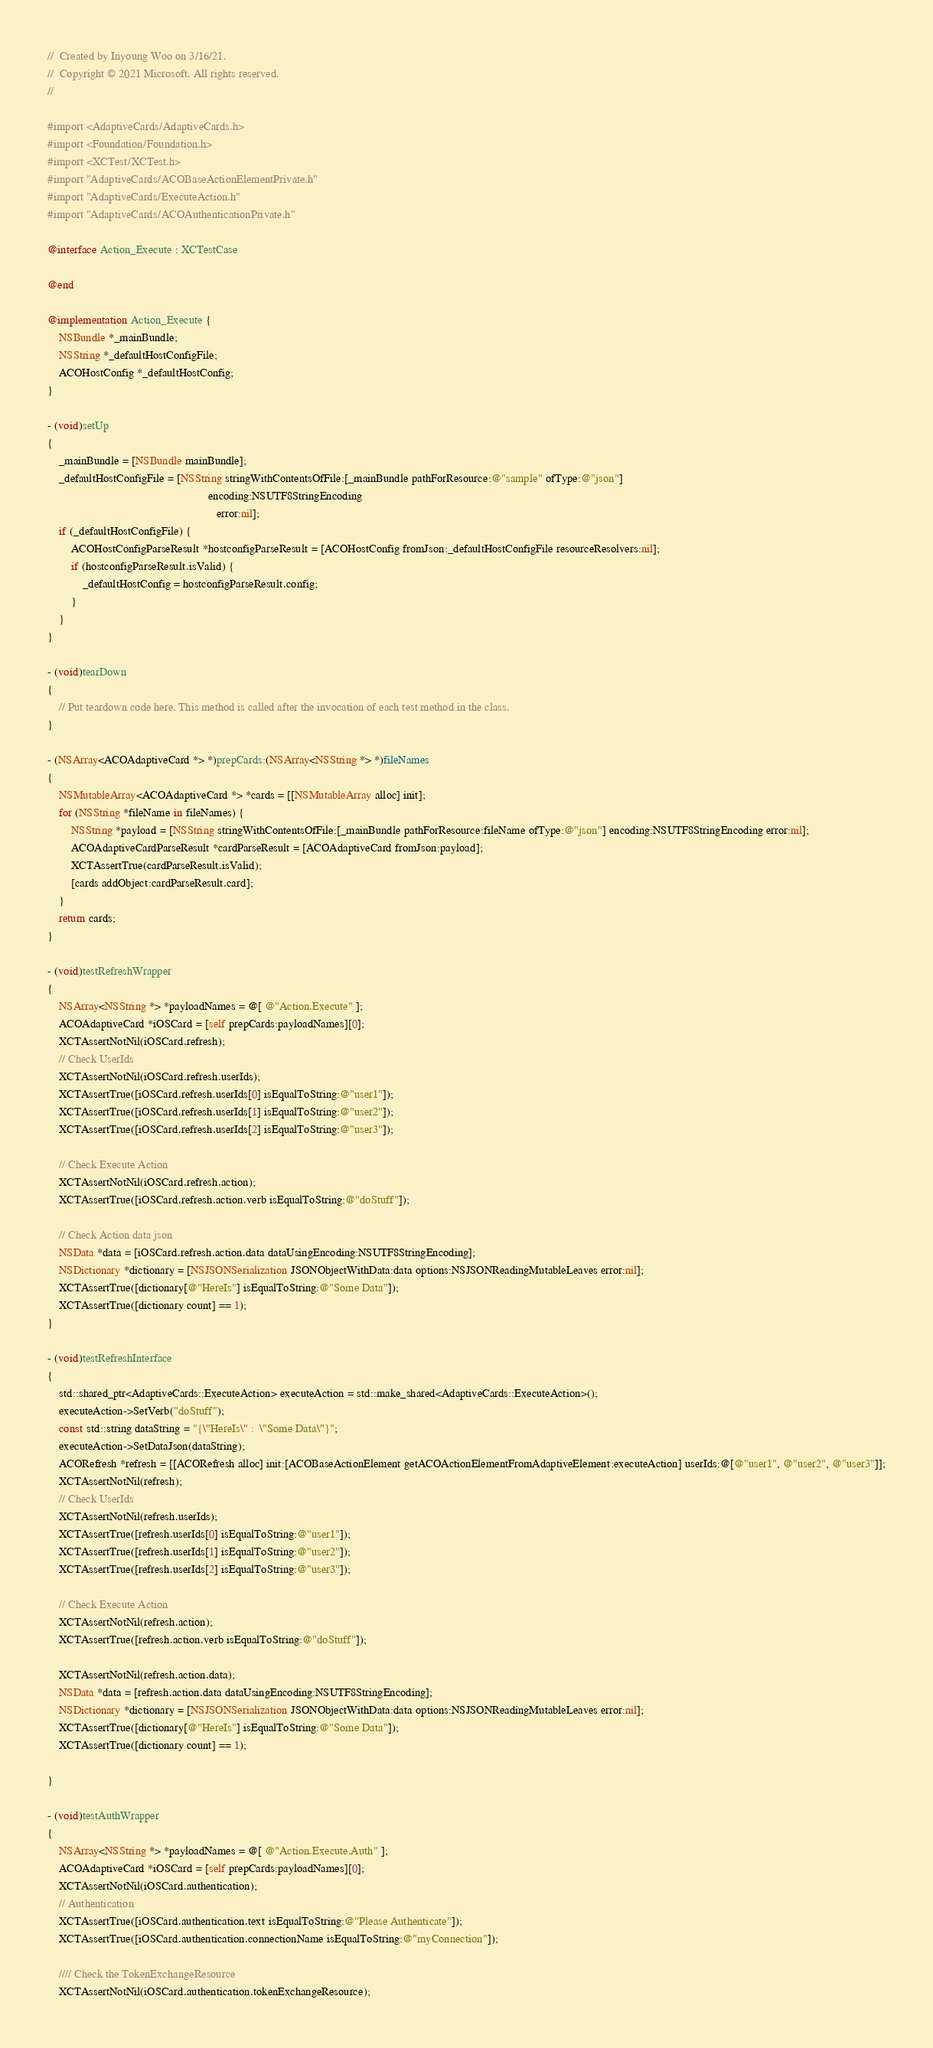Convert code to text. <code><loc_0><loc_0><loc_500><loc_500><_ObjectiveC_>//  Created by Inyoung Woo on 3/16/21.
//  Copyright © 2021 Microsoft. All rights reserved.
//

#import <AdaptiveCards/AdaptiveCards.h>
#import <Foundation/Foundation.h>
#import <XCTest/XCTest.h>
#import "AdaptiveCards/ACOBaseActionElementPrivate.h"
#import "AdaptiveCards/ExecuteAction.h"
#import "AdaptiveCards/ACOAuthenticationPrivate.h"

@interface Action_Execute : XCTestCase

@end

@implementation Action_Execute {
    NSBundle *_mainBundle;
    NSString *_defaultHostConfigFile;
    ACOHostConfig *_defaultHostConfig;
}

- (void)setUp
{
    _mainBundle = [NSBundle mainBundle];
    _defaultHostConfigFile = [NSString stringWithContentsOfFile:[_mainBundle pathForResource:@"sample" ofType:@"json"]
                                                       encoding:NSUTF8StringEncoding
                                                          error:nil];
    if (_defaultHostConfigFile) {
        ACOHostConfigParseResult *hostconfigParseResult = [ACOHostConfig fromJson:_defaultHostConfigFile resourceResolvers:nil];
        if (hostconfigParseResult.isValid) {
            _defaultHostConfig = hostconfigParseResult.config;
        }
    }
}

- (void)tearDown
{
    // Put teardown code here. This method is called after the invocation of each test method in the class.
}

- (NSArray<ACOAdaptiveCard *> *)prepCards:(NSArray<NSString *> *)fileNames
{
    NSMutableArray<ACOAdaptiveCard *> *cards = [[NSMutableArray alloc] init];
    for (NSString *fileName in fileNames) {
        NSString *payload = [NSString stringWithContentsOfFile:[_mainBundle pathForResource:fileName ofType:@"json"] encoding:NSUTF8StringEncoding error:nil];
        ACOAdaptiveCardParseResult *cardParseResult = [ACOAdaptiveCard fromJson:payload];
        XCTAssertTrue(cardParseResult.isValid);
        [cards addObject:cardParseResult.card];
    }
    return cards;
}

- (void)testRefreshWrapper
{
    NSArray<NSString *> *payloadNames = @[ @"Action.Execute" ];
    ACOAdaptiveCard *iOSCard = [self prepCards:payloadNames][0];
    XCTAssertNotNil(iOSCard.refresh);
    // Check UserIds
    XCTAssertNotNil(iOSCard.refresh.userIds);
    XCTAssertTrue([iOSCard.refresh.userIds[0] isEqualToString:@"user1"]);
    XCTAssertTrue([iOSCard.refresh.userIds[1] isEqualToString:@"user2"]);
    XCTAssertTrue([iOSCard.refresh.userIds[2] isEqualToString:@"user3"]);

    // Check Execute Action
    XCTAssertNotNil(iOSCard.refresh.action);
    XCTAssertTrue([iOSCard.refresh.action.verb isEqualToString:@"doStuff"]);

    // Check Action data json
    NSData *data = [iOSCard.refresh.action.data dataUsingEncoding:NSUTF8StringEncoding];
    NSDictionary *dictionary = [NSJSONSerialization JSONObjectWithData:data options:NSJSONReadingMutableLeaves error:nil];
    XCTAssertTrue([dictionary[@"HereIs"] isEqualToString:@"Some Data"]);
    XCTAssertTrue([dictionary count] == 1);
}

- (void)testRefreshInterface
{
    std::shared_ptr<AdaptiveCards::ExecuteAction> executeAction = std::make_shared<AdaptiveCards::ExecuteAction>();
    executeAction->SetVerb("doStuff");
    const std::string dataString = "{\"HereIs\" :  \"Some Data\"}";
    executeAction->SetDataJson(dataString);
    ACORefresh *refresh = [[ACORefresh alloc] init:[ACOBaseActionElement getACOActionElementFromAdaptiveElement:executeAction] userIds:@[@"user1", @"user2", @"user3"]];
    XCTAssertNotNil(refresh);
    // Check UserIds
    XCTAssertNotNil(refresh.userIds);
    XCTAssertTrue([refresh.userIds[0] isEqualToString:@"user1"]);
    XCTAssertTrue([refresh.userIds[1] isEqualToString:@"user2"]);
    XCTAssertTrue([refresh.userIds[2] isEqualToString:@"user3"]);
    
    // Check Execute Action
    XCTAssertNotNil(refresh.action);
    XCTAssertTrue([refresh.action.verb isEqualToString:@"doStuff"]);
    
    XCTAssertNotNil(refresh.action.data);
    NSData *data = [refresh.action.data dataUsingEncoding:NSUTF8StringEncoding];
    NSDictionary *dictionary = [NSJSONSerialization JSONObjectWithData:data options:NSJSONReadingMutableLeaves error:nil];
    XCTAssertTrue([dictionary[@"HereIs"] isEqualToString:@"Some Data"]);
    XCTAssertTrue([dictionary count] == 1);
    
}

- (void)testAuthWrapper
{
    NSArray<NSString *> *payloadNames = @[ @"Action.Execute.Auth" ];
    ACOAdaptiveCard *iOSCard = [self prepCards:payloadNames][0];
    XCTAssertNotNil(iOSCard.authentication);
    // Authentication
    XCTAssertTrue([iOSCard.authentication.text isEqualToString:@"Please Authenticate"]);
    XCTAssertTrue([iOSCard.authentication.connectionName isEqualToString:@"myConnection"]);

    //// Check the TokenExchangeResource
    XCTAssertNotNil(iOSCard.authentication.tokenExchangeResource);</code> 